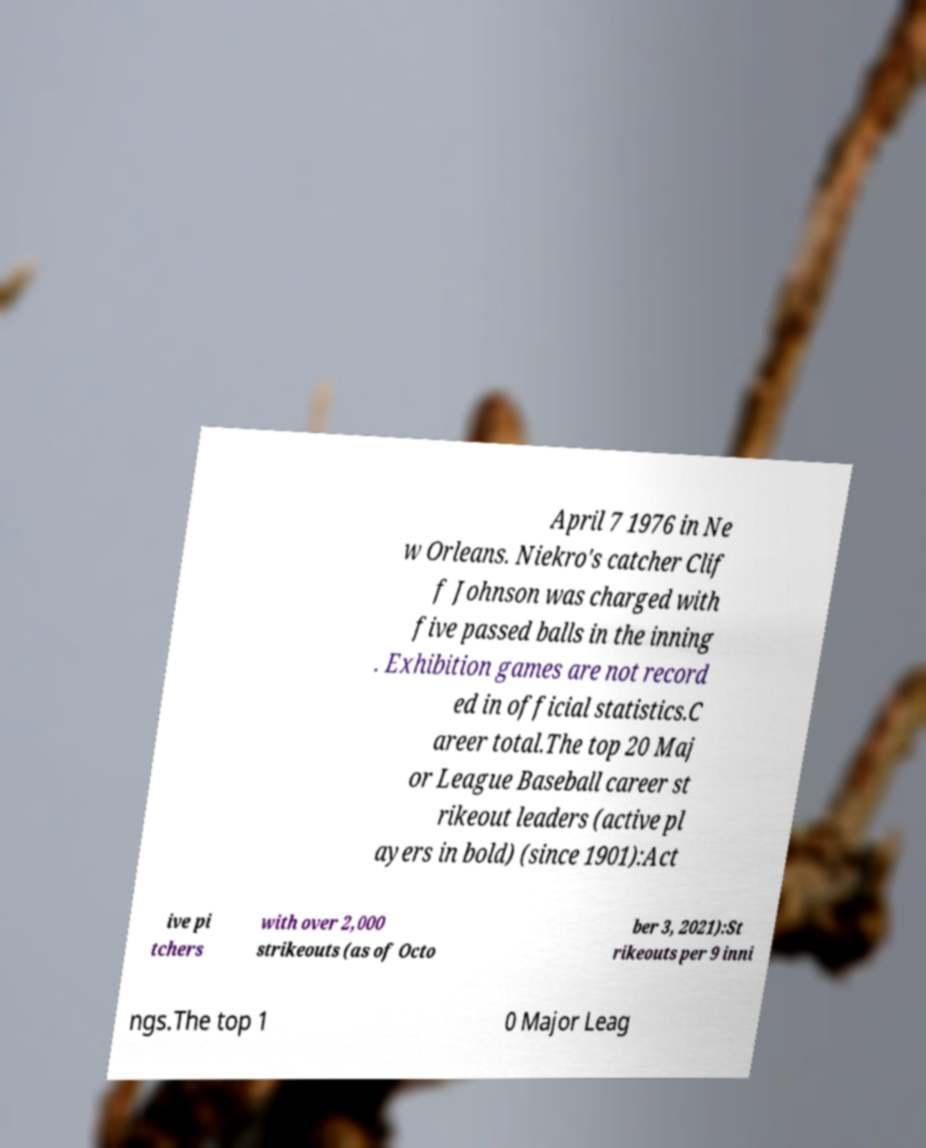Can you accurately transcribe the text from the provided image for me? April 7 1976 in Ne w Orleans. Niekro's catcher Clif f Johnson was charged with five passed balls in the inning . Exhibition games are not record ed in official statistics.C areer total.The top 20 Maj or League Baseball career st rikeout leaders (active pl ayers in bold) (since 1901):Act ive pi tchers with over 2,000 strikeouts (as of Octo ber 3, 2021):St rikeouts per 9 inni ngs.The top 1 0 Major Leag 